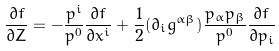<formula> <loc_0><loc_0><loc_500><loc_500>\frac { \partial f } { \partial Z } = - \frac { p ^ { i } } { p ^ { 0 } } \frac { \partial f } { \partial x ^ { i } } + \frac { 1 } { 2 } ( \partial _ { i } g ^ { \alpha \beta } ) \frac { p _ { \alpha } p _ { \beta } } { p ^ { 0 } } \frac { \partial f } { \partial p _ { i } }</formula> 